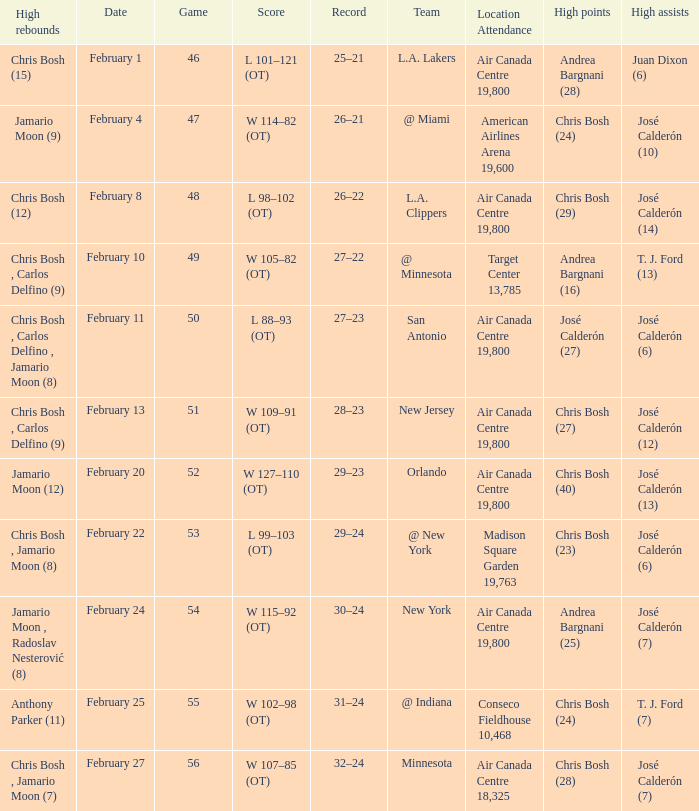Parse the full table. {'header': ['High rebounds', 'Date', 'Game', 'Score', 'Record', 'Team', 'Location Attendance', 'High points', 'High assists'], 'rows': [['Chris Bosh (15)', 'February 1', '46', 'L 101–121 (OT)', '25–21', 'L.A. Lakers', 'Air Canada Centre 19,800', 'Andrea Bargnani (28)', 'Juan Dixon (6)'], ['Jamario Moon (9)', 'February 4', '47', 'W 114–82 (OT)', '26–21', '@ Miami', 'American Airlines Arena 19,600', 'Chris Bosh (24)', 'José Calderón (10)'], ['Chris Bosh (12)', 'February 8', '48', 'L 98–102 (OT)', '26–22', 'L.A. Clippers', 'Air Canada Centre 19,800', 'Chris Bosh (29)', 'José Calderón (14)'], ['Chris Bosh , Carlos Delfino (9)', 'February 10', '49', 'W 105–82 (OT)', '27–22', '@ Minnesota', 'Target Center 13,785', 'Andrea Bargnani (16)', 'T. J. Ford (13)'], ['Chris Bosh , Carlos Delfino , Jamario Moon (8)', 'February 11', '50', 'L 88–93 (OT)', '27–23', 'San Antonio', 'Air Canada Centre 19,800', 'José Calderón (27)', 'José Calderón (6)'], ['Chris Bosh , Carlos Delfino (9)', 'February 13', '51', 'W 109–91 (OT)', '28–23', 'New Jersey', 'Air Canada Centre 19,800', 'Chris Bosh (27)', 'José Calderón (12)'], ['Jamario Moon (12)', 'February 20', '52', 'W 127–110 (OT)', '29–23', 'Orlando', 'Air Canada Centre 19,800', 'Chris Bosh (40)', 'José Calderón (13)'], ['Chris Bosh , Jamario Moon (8)', 'February 22', '53', 'L 99–103 (OT)', '29–24', '@ New York', 'Madison Square Garden 19,763', 'Chris Bosh (23)', 'José Calderón (6)'], ['Jamario Moon , Radoslav Nesterović (8)', 'February 24', '54', 'W 115–92 (OT)', '30–24', 'New York', 'Air Canada Centre 19,800', 'Andrea Bargnani (25)', 'José Calderón (7)'], ['Anthony Parker (11)', 'February 25', '55', 'W 102–98 (OT)', '31–24', '@ Indiana', 'Conseco Fieldhouse 10,468', 'Chris Bosh (24)', 'T. J. Ford (7)'], ['Chris Bosh , Jamario Moon (7)', 'February 27', '56', 'W 107–85 (OT)', '32–24', 'Minnesota', 'Air Canada Centre 18,325', 'Chris Bosh (28)', 'José Calderón (7)']]} Who scored the most points in Game 49? Andrea Bargnani (16). 